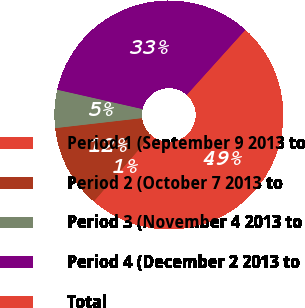Convert chart. <chart><loc_0><loc_0><loc_500><loc_500><pie_chart><fcel>Period 1 (September 9 2013 to<fcel>Period 2 (October 7 2013 to<fcel>Period 3 (November 4 2013 to<fcel>Period 4 (December 2 2013 to<fcel>Total<nl><fcel>0.51%<fcel>11.79%<fcel>5.38%<fcel>33.12%<fcel>49.2%<nl></chart> 